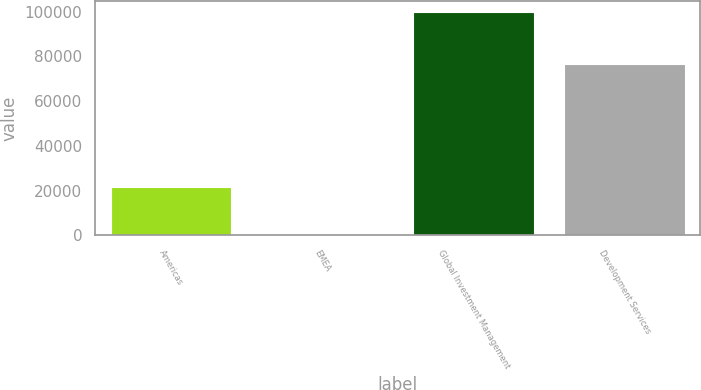Convert chart. <chart><loc_0><loc_0><loc_500><loc_500><bar_chart><fcel>Americas<fcel>EMEA<fcel>Global Investment Management<fcel>Development Services<nl><fcel>21777<fcel>414<fcel>99714<fcel>76791<nl></chart> 